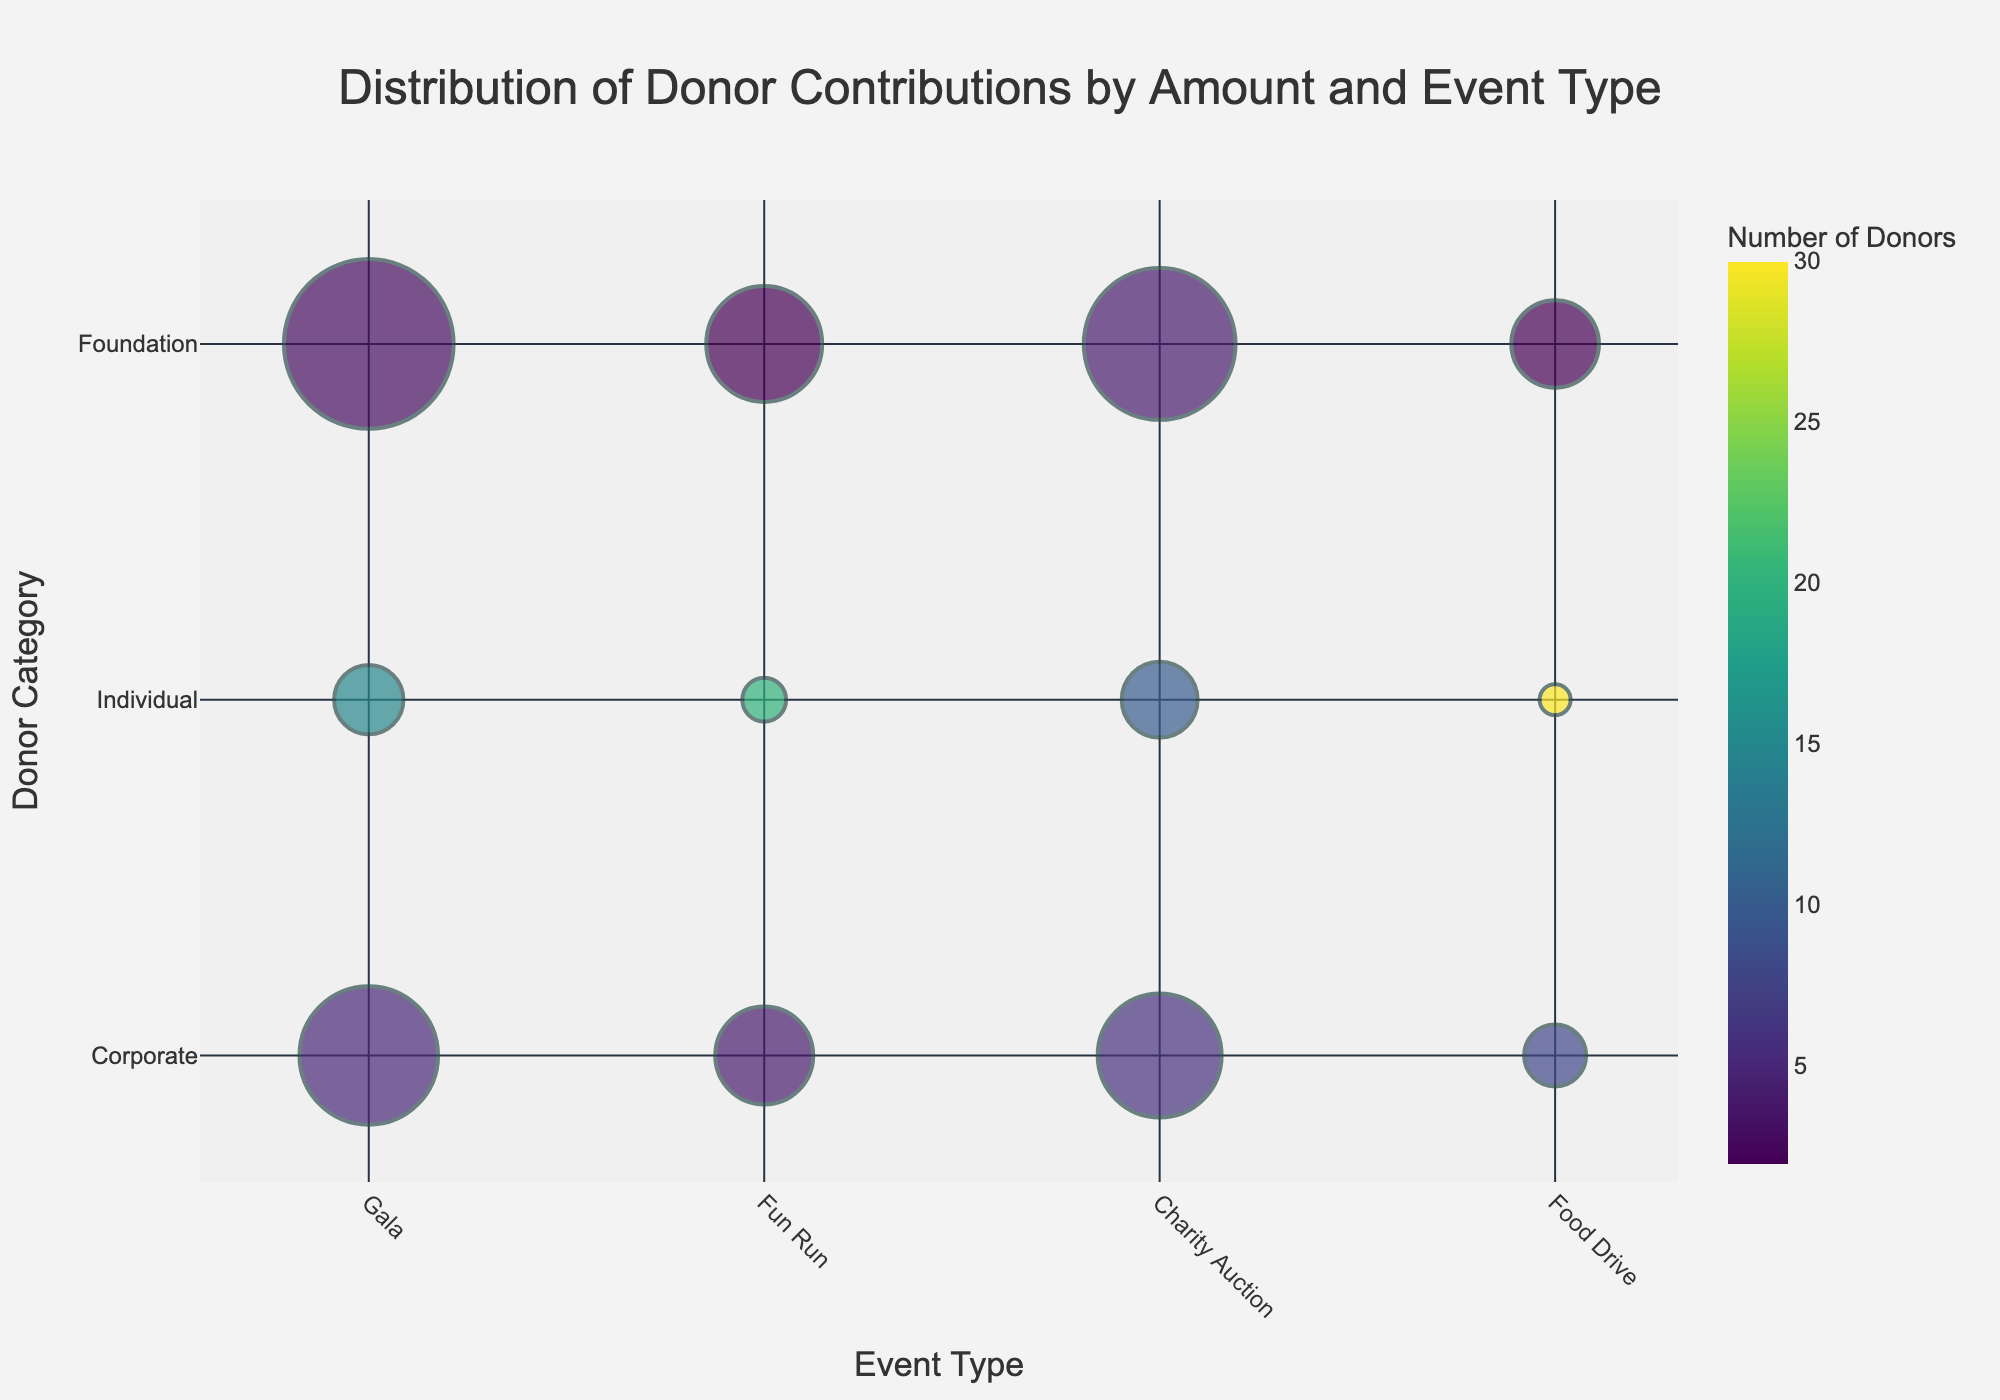What is the title of the figure? The title is usually found at the top of the figure, which provides an overview of what the chart represents. In this case, you can read it directly from the figure.
Answer: Distribution of Donor Contributions by Amount and Event Type Which Event Type has the most bubbles? To determine this, count the number of bubbles for each Event Type along the x-axis, then compare the counts.
Answer: Gala What is the contribution amount for Corporate donors at the Gala event? Look for the Gala event on the x-axis and then find the bubble in the Corporate row. Check the size of this bubble against the legend for Contribution Amount.
Answer: $10,000 Between Individual and Foundation donors at the Fun Run, which category has more number of donors? Locate Fun Run on the x-axis, then compare the colors of bubbles for Individual and Foundation to see which has more donors based on the color gradient.
Answer: Individual What is the smallest contribution amount represented in the chart? Check the size of the smallest bubbles and read the Contribution Amount from the legend. With Contribution Amount provided, identify the smallest value.
Answer: $500 Which Donor Category has the highest total contribution amount across all events? Sum the Contribution Amount for each Donor Category across the different events and compare the totals. 
Corporate: $34,000 (10000+5000+8000+2000) 
Individual: $7,000 (2500+1000+3000+500)
Foundation: $38,000 (15000+7000+12000+4000)
The highest total is for Foundation donors.
Answer: Foundation Do Corporate donors have a higher contribution amount for the Fun Run or the Charity Auction? Compare the sizes of the bubbles for Corporate donors at the Fun Run and Charity Auction events.
Answer: Charity Auction How many more donors contributed as Individuals compared to Foundations at the Food Drive? Find the number of donors for both Individuals and Foundations at the Food Drive, then subtract the smaller number from the larger number. Individual: 30, Foundation: 2, so the difference is 30 - 2.
Answer: 28 Which has a larger contribution amount: Corporate donors at the Fun Run or Individual donors at the Gala? Compare the size of the bubbles for Corporate donors at the Fun Run and Individual donors at the Gala.
Answer: Corporate donors at the Fun Run How do Foundation contributions compare between the Fun Run and the Charity Auction? Compare the sizes of the bubbles for Foundation at the Fun Run and Charity Auction events.
Answer: Charity Auction has a larger contribution amount than Fun Run for Foundation 